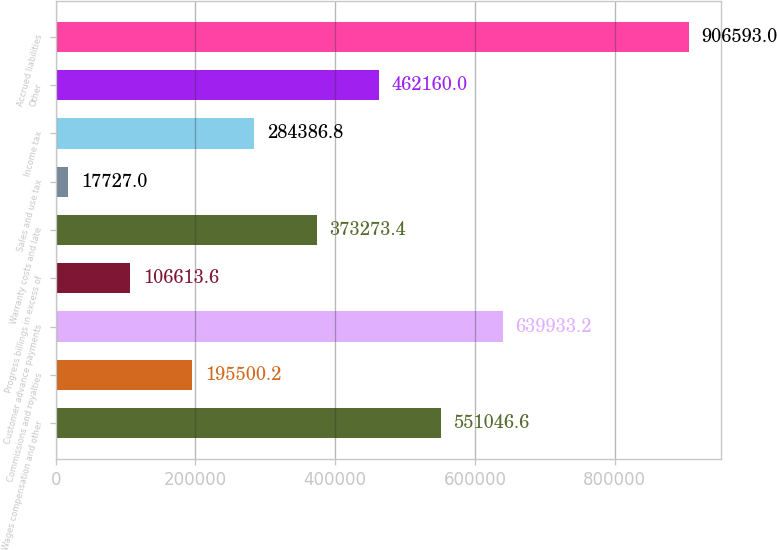<chart> <loc_0><loc_0><loc_500><loc_500><bar_chart><fcel>Wages compensation and other<fcel>Commissions and royalties<fcel>Customer advance payments<fcel>Progress billings in excess of<fcel>Warranty costs and late<fcel>Sales and use tax<fcel>Income tax<fcel>Other<fcel>Accrued liabilities<nl><fcel>551047<fcel>195500<fcel>639933<fcel>106614<fcel>373273<fcel>17727<fcel>284387<fcel>462160<fcel>906593<nl></chart> 